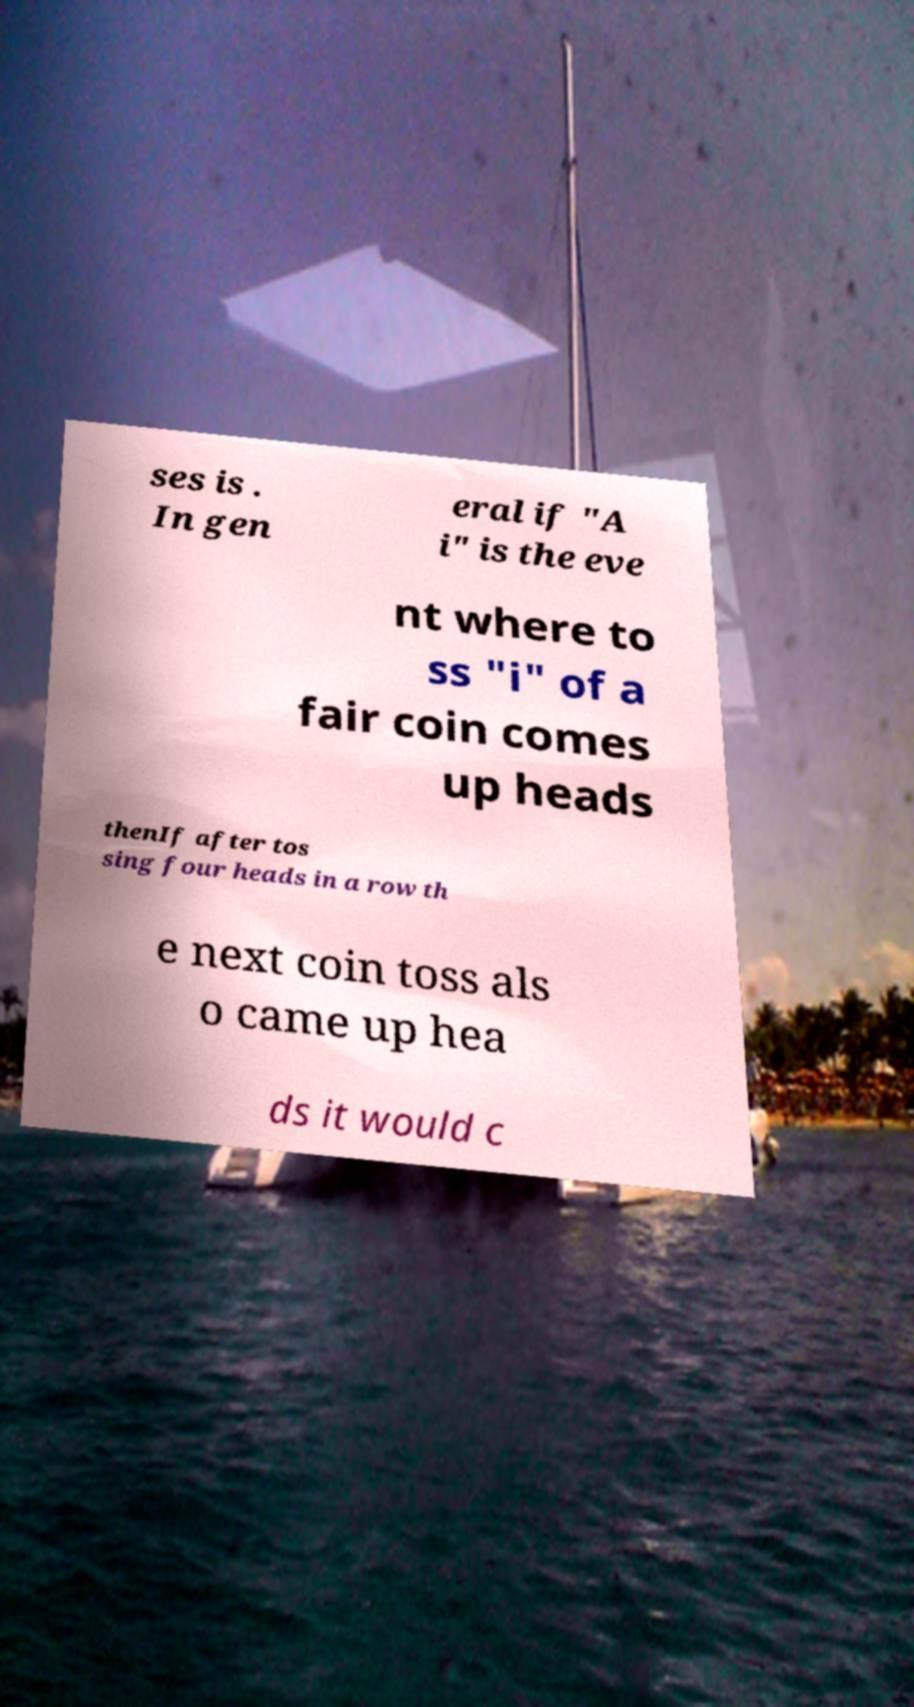Can you accurately transcribe the text from the provided image for me? ses is . In gen eral if "A i" is the eve nt where to ss "i" of a fair coin comes up heads thenIf after tos sing four heads in a row th e next coin toss als o came up hea ds it would c 